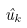Convert formula to latex. <formula><loc_0><loc_0><loc_500><loc_500>\hat { u } _ { k }</formula> 